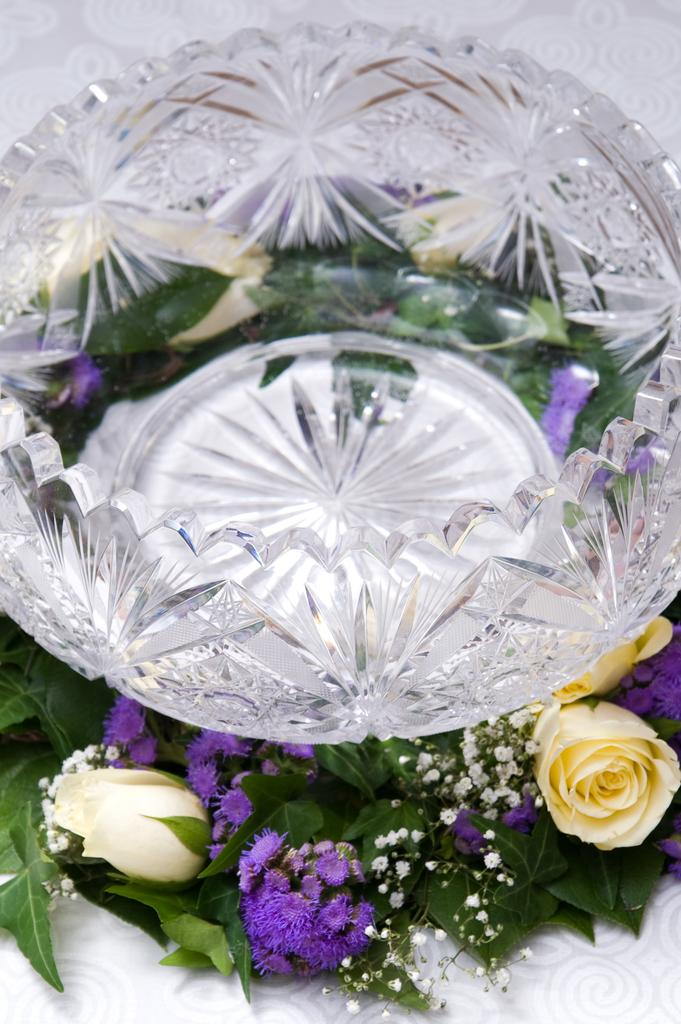What type of living organisms can be seen in the image? There are flowers in the image. What colors are the flowers? The flowers are in cream and purple colors. What is the surface on which the flowers are placed? The flowers are on a white surface. What other object can be seen in the image? There is a glass bowl in the image. What type of drug can be seen in the image? There is no drug present in the image; it features flowers on a white surface and a glass bowl. 